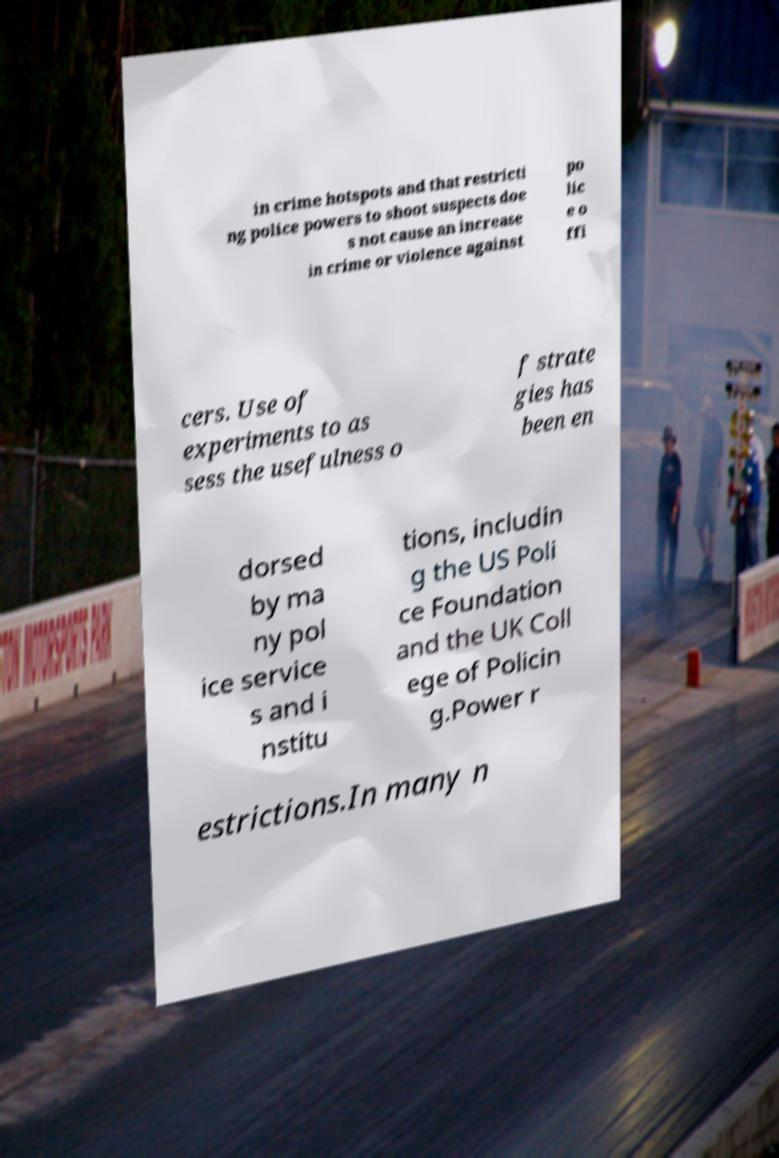Can you accurately transcribe the text from the provided image for me? in crime hotspots and that restricti ng police powers to shoot suspects doe s not cause an increase in crime or violence against po lic e o ffi cers. Use of experiments to as sess the usefulness o f strate gies has been en dorsed by ma ny pol ice service s and i nstitu tions, includin g the US Poli ce Foundation and the UK Coll ege of Policin g.Power r estrictions.In many n 